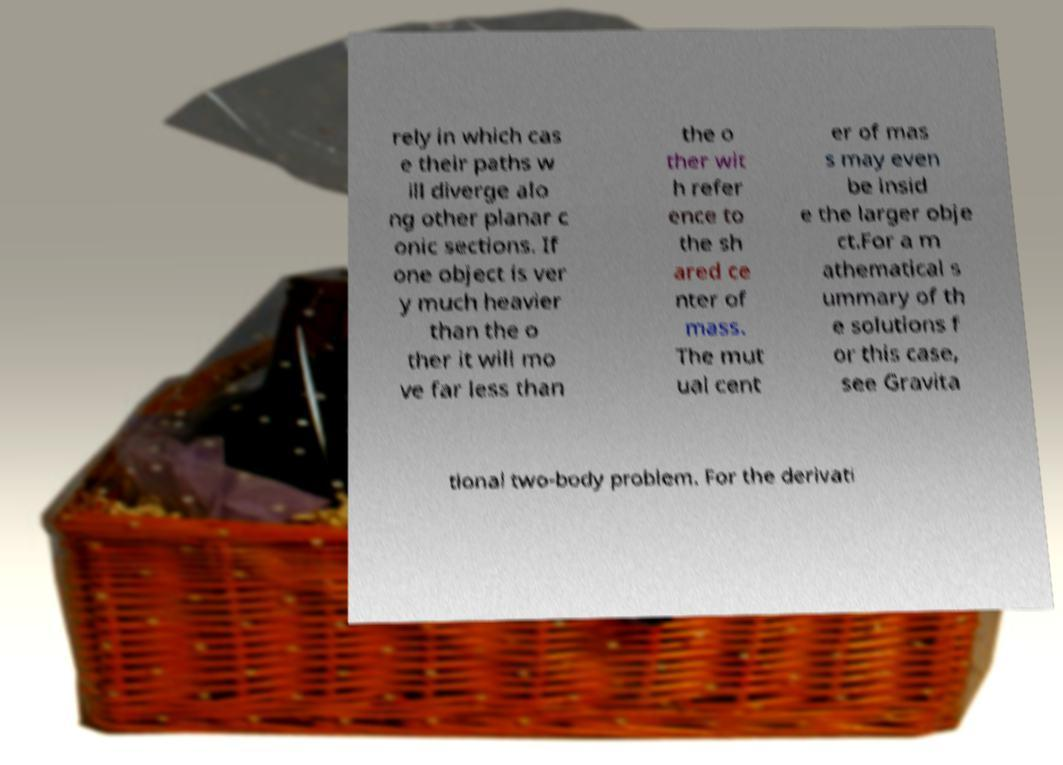Please identify and transcribe the text found in this image. rely in which cas e their paths w ill diverge alo ng other planar c onic sections. If one object is ver y much heavier than the o ther it will mo ve far less than the o ther wit h refer ence to the sh ared ce nter of mass. The mut ual cent er of mas s may even be insid e the larger obje ct.For a m athematical s ummary of th e solutions f or this case, see Gravita tional two-body problem. For the derivati 